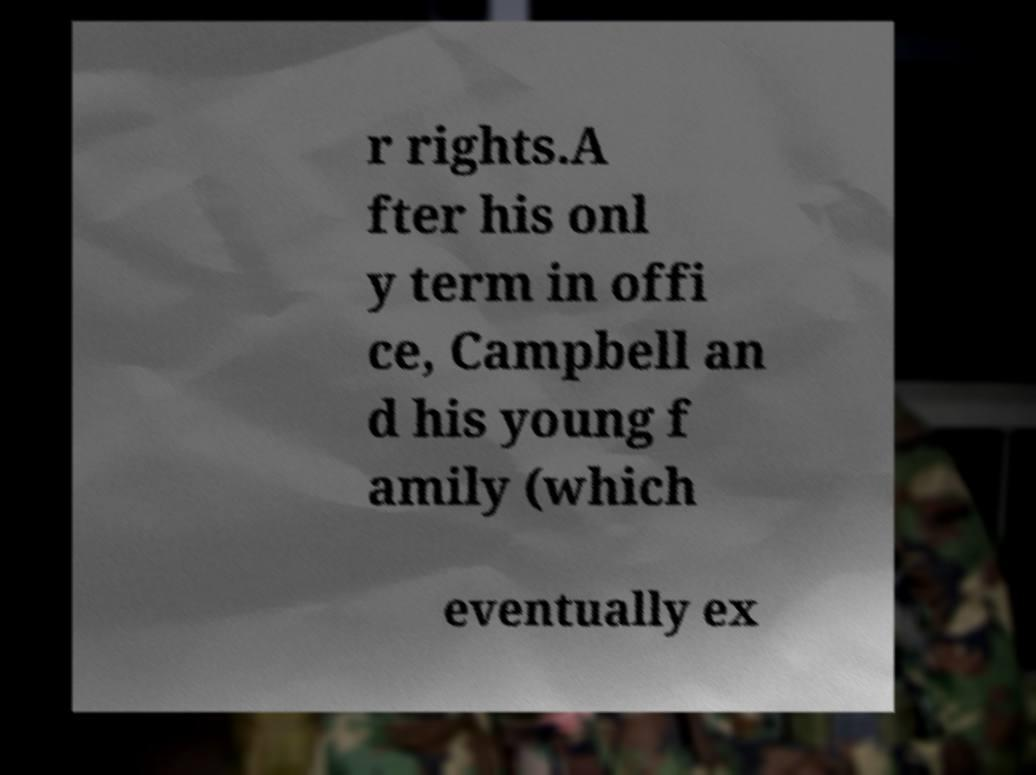What messages or text are displayed in this image? I need them in a readable, typed format. r rights.A fter his onl y term in offi ce, Campbell an d his young f amily (which eventually ex 